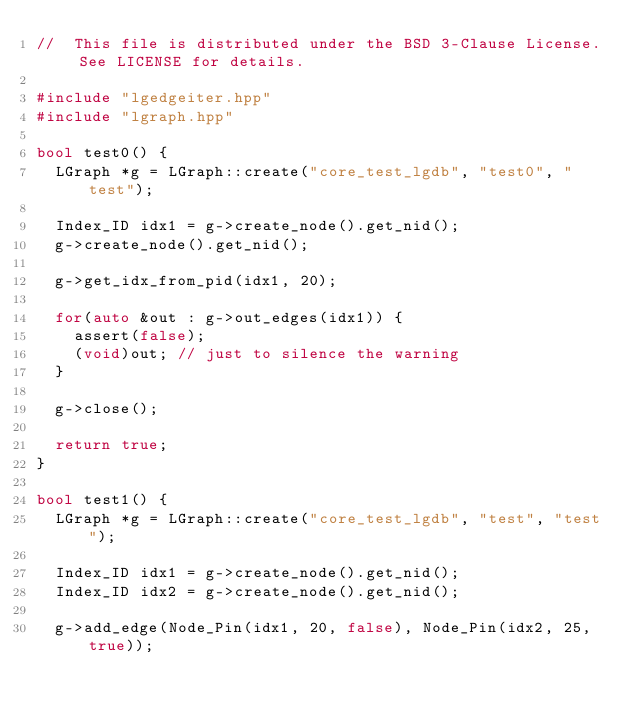Convert code to text. <code><loc_0><loc_0><loc_500><loc_500><_C++_>//  This file is distributed under the BSD 3-Clause License. See LICENSE for details.

#include "lgedgeiter.hpp"
#include "lgraph.hpp"

bool test0() {
  LGraph *g = LGraph::create("core_test_lgdb", "test0", "test");

  Index_ID idx1 = g->create_node().get_nid();
  g->create_node().get_nid();

  g->get_idx_from_pid(idx1, 20);

  for(auto &out : g->out_edges(idx1)) {
    assert(false);
    (void)out; // just to silence the warning
  }

  g->close();

  return true;
}

bool test1() {
  LGraph *g = LGraph::create("core_test_lgdb", "test", "test");

  Index_ID idx1 = g->create_node().get_nid();
  Index_ID idx2 = g->create_node().get_nid();

  g->add_edge(Node_Pin(idx1, 20, false), Node_Pin(idx2, 25, true));
</code> 